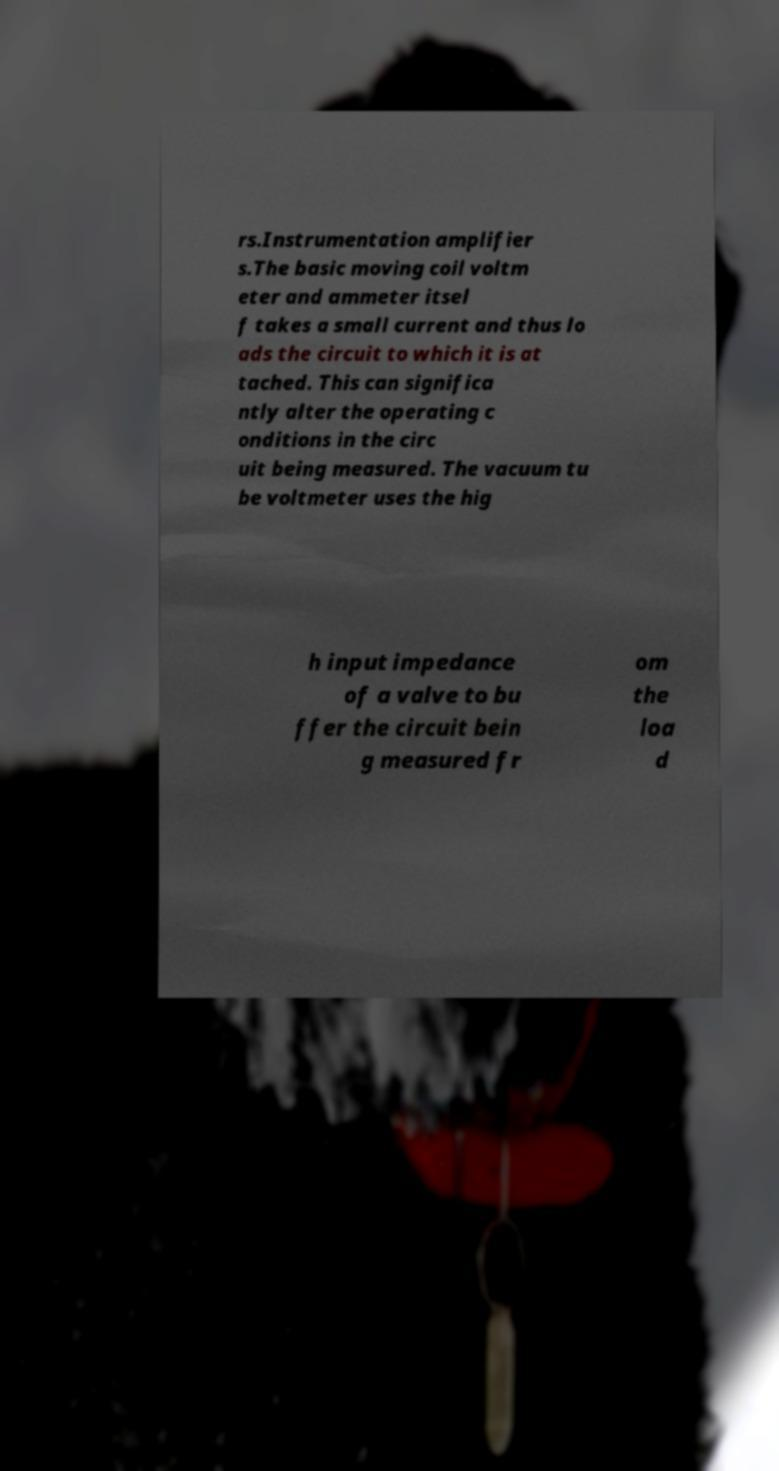Please identify and transcribe the text found in this image. rs.Instrumentation amplifier s.The basic moving coil voltm eter and ammeter itsel f takes a small current and thus lo ads the circuit to which it is at tached. This can significa ntly alter the operating c onditions in the circ uit being measured. The vacuum tu be voltmeter uses the hig h input impedance of a valve to bu ffer the circuit bein g measured fr om the loa d 